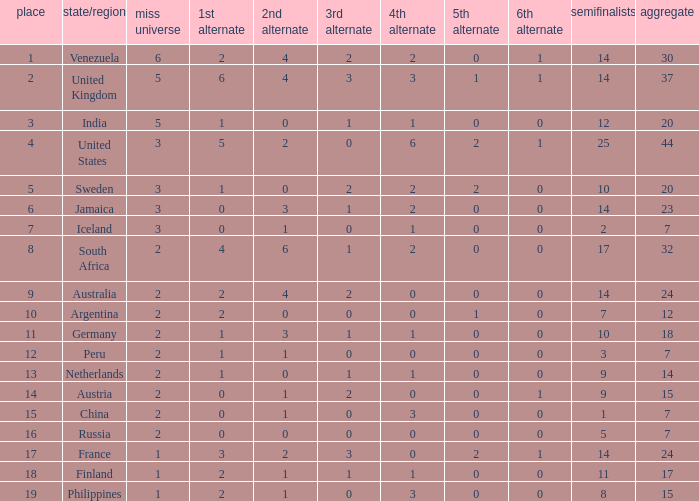Which countries have a 5th runner-up ranking is 2 and the 3rd runner-up ranking is 0 44.0. 